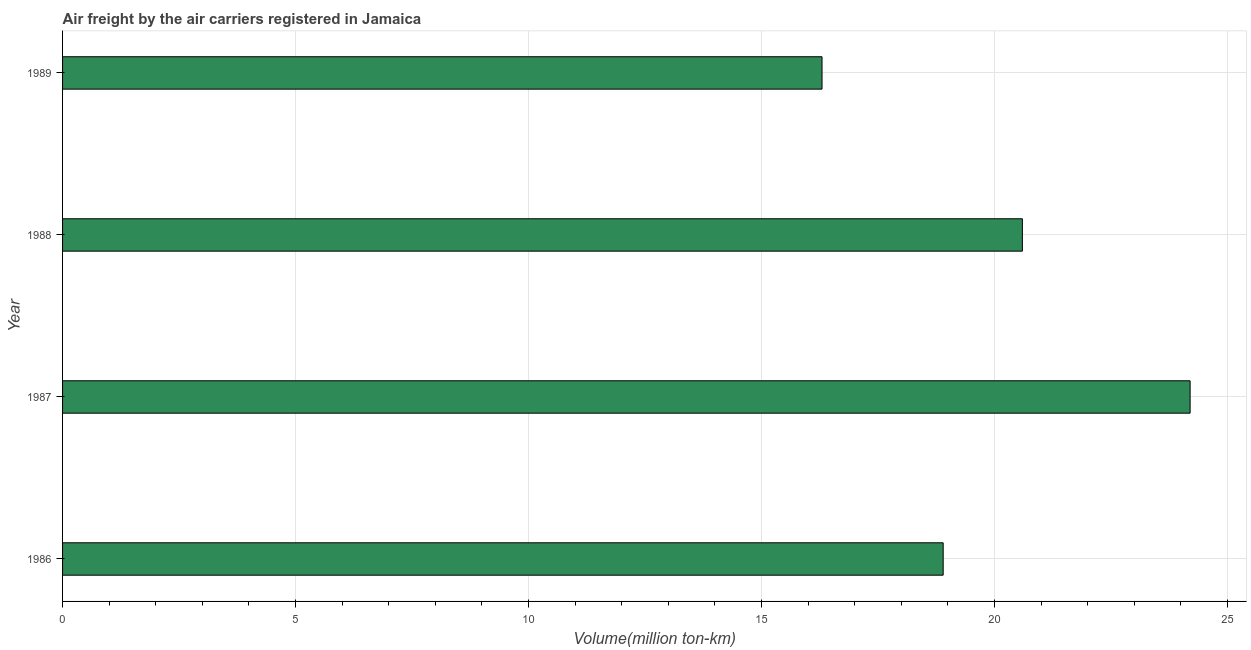Does the graph contain any zero values?
Your answer should be compact. No. What is the title of the graph?
Offer a terse response. Air freight by the air carriers registered in Jamaica. What is the label or title of the X-axis?
Your answer should be very brief. Volume(million ton-km). What is the label or title of the Y-axis?
Keep it short and to the point. Year. What is the air freight in 1989?
Your answer should be compact. 16.3. Across all years, what is the maximum air freight?
Give a very brief answer. 24.2. Across all years, what is the minimum air freight?
Your answer should be compact. 16.3. What is the average air freight per year?
Offer a terse response. 20. What is the median air freight?
Provide a succinct answer. 19.75. What is the ratio of the air freight in 1988 to that in 1989?
Offer a terse response. 1.26. What is the difference between the highest and the lowest air freight?
Ensure brevity in your answer.  7.9. In how many years, is the air freight greater than the average air freight taken over all years?
Provide a short and direct response. 2. How many bars are there?
Offer a very short reply. 4. What is the difference between two consecutive major ticks on the X-axis?
Give a very brief answer. 5. What is the Volume(million ton-km) of 1986?
Give a very brief answer. 18.9. What is the Volume(million ton-km) of 1987?
Your answer should be compact. 24.2. What is the Volume(million ton-km) of 1988?
Offer a terse response. 20.6. What is the Volume(million ton-km) of 1989?
Make the answer very short. 16.3. What is the difference between the Volume(million ton-km) in 1986 and 1987?
Offer a terse response. -5.3. What is the difference between the Volume(million ton-km) in 1986 and 1988?
Make the answer very short. -1.7. What is the difference between the Volume(million ton-km) in 1986 and 1989?
Your response must be concise. 2.6. What is the difference between the Volume(million ton-km) in 1987 and 1988?
Offer a very short reply. 3.6. What is the difference between the Volume(million ton-km) in 1987 and 1989?
Ensure brevity in your answer.  7.9. What is the difference between the Volume(million ton-km) in 1988 and 1989?
Your response must be concise. 4.3. What is the ratio of the Volume(million ton-km) in 1986 to that in 1987?
Keep it short and to the point. 0.78. What is the ratio of the Volume(million ton-km) in 1986 to that in 1988?
Make the answer very short. 0.92. What is the ratio of the Volume(million ton-km) in 1986 to that in 1989?
Your answer should be very brief. 1.16. What is the ratio of the Volume(million ton-km) in 1987 to that in 1988?
Give a very brief answer. 1.18. What is the ratio of the Volume(million ton-km) in 1987 to that in 1989?
Offer a very short reply. 1.49. What is the ratio of the Volume(million ton-km) in 1988 to that in 1989?
Your answer should be compact. 1.26. 